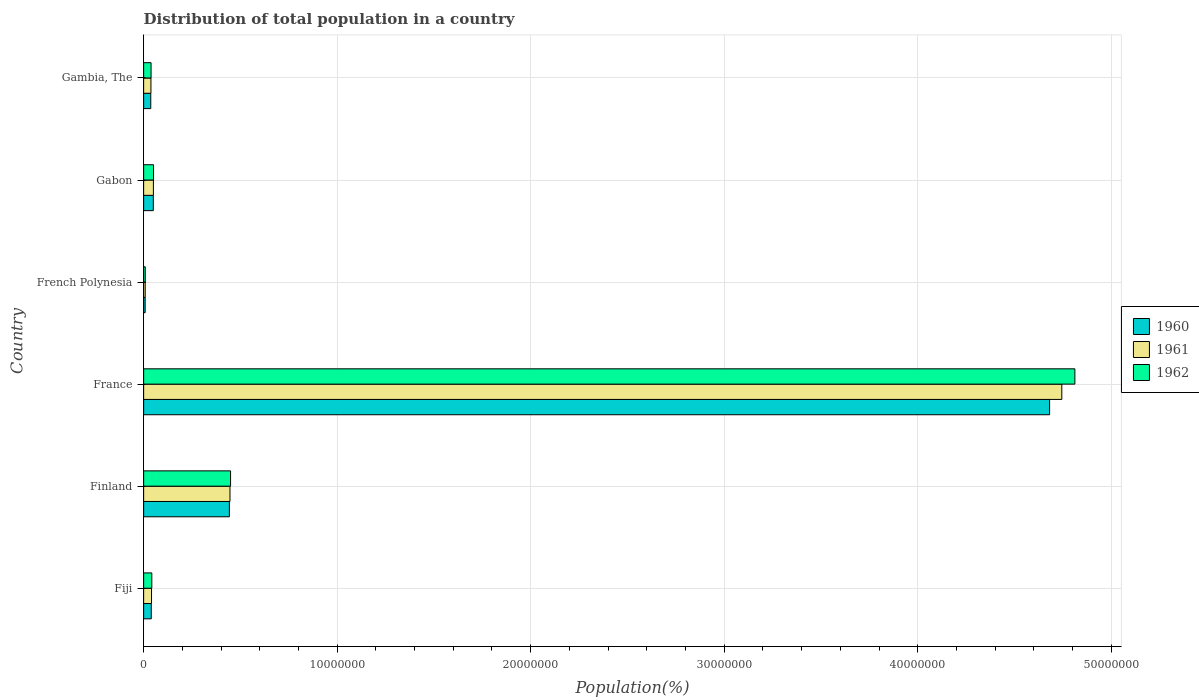What is the label of the 2nd group of bars from the top?
Keep it short and to the point. Gabon. In how many cases, is the number of bars for a given country not equal to the number of legend labels?
Give a very brief answer. 0. What is the population of in 1962 in Gabon?
Your answer should be compact. 5.10e+05. Across all countries, what is the maximum population of in 1960?
Provide a succinct answer. 4.68e+07. Across all countries, what is the minimum population of in 1961?
Provide a succinct answer. 8.07e+04. In which country was the population of in 1961 maximum?
Make the answer very short. France. In which country was the population of in 1960 minimum?
Ensure brevity in your answer.  French Polynesia. What is the total population of in 1962 in the graph?
Offer a very short reply. 5.40e+07. What is the difference between the population of in 1961 in Gabon and that in Gambia, The?
Your response must be concise. 1.27e+05. What is the difference between the population of in 1962 in Gambia, The and the population of in 1960 in Fiji?
Offer a very short reply. -9858. What is the average population of in 1961 per country?
Offer a terse response. 8.88e+06. What is the difference between the population of in 1962 and population of in 1961 in French Polynesia?
Ensure brevity in your answer.  2948. In how many countries, is the population of in 1962 greater than 46000000 %?
Your answer should be very brief. 1. What is the ratio of the population of in 1962 in Finland to that in Gambia, The?
Your response must be concise. 11.71. Is the difference between the population of in 1962 in Fiji and Gambia, The greater than the difference between the population of in 1961 in Fiji and Gambia, The?
Offer a terse response. Yes. What is the difference between the highest and the second highest population of in 1961?
Ensure brevity in your answer.  4.30e+07. What is the difference between the highest and the lowest population of in 1960?
Your answer should be very brief. 4.67e+07. What does the 2nd bar from the top in Gabon represents?
Your answer should be very brief. 1961. What does the 1st bar from the bottom in French Polynesia represents?
Make the answer very short. 1960. Is it the case that in every country, the sum of the population of in 1961 and population of in 1960 is greater than the population of in 1962?
Offer a very short reply. Yes. How many bars are there?
Your response must be concise. 18. How many countries are there in the graph?
Provide a succinct answer. 6. What is the difference between two consecutive major ticks on the X-axis?
Make the answer very short. 1.00e+07. Are the values on the major ticks of X-axis written in scientific E-notation?
Your response must be concise. No. How are the legend labels stacked?
Give a very brief answer. Vertical. What is the title of the graph?
Offer a very short reply. Distribution of total population in a country. Does "1968" appear as one of the legend labels in the graph?
Your response must be concise. No. What is the label or title of the X-axis?
Keep it short and to the point. Population(%). What is the Population(%) of 1960 in Fiji?
Offer a terse response. 3.93e+05. What is the Population(%) in 1961 in Fiji?
Keep it short and to the point. 4.07e+05. What is the Population(%) in 1962 in Fiji?
Provide a short and direct response. 4.22e+05. What is the Population(%) in 1960 in Finland?
Make the answer very short. 4.43e+06. What is the Population(%) in 1961 in Finland?
Your answer should be very brief. 4.46e+06. What is the Population(%) in 1962 in Finland?
Make the answer very short. 4.49e+06. What is the Population(%) in 1960 in France?
Your answer should be compact. 4.68e+07. What is the Population(%) in 1961 in France?
Ensure brevity in your answer.  4.74e+07. What is the Population(%) of 1962 in France?
Your response must be concise. 4.81e+07. What is the Population(%) in 1960 in French Polynesia?
Offer a very short reply. 7.81e+04. What is the Population(%) of 1961 in French Polynesia?
Your answer should be very brief. 8.07e+04. What is the Population(%) of 1962 in French Polynesia?
Make the answer very short. 8.37e+04. What is the Population(%) in 1960 in Gabon?
Make the answer very short. 4.99e+05. What is the Population(%) of 1961 in Gabon?
Keep it short and to the point. 5.04e+05. What is the Population(%) of 1962 in Gabon?
Ensure brevity in your answer.  5.10e+05. What is the Population(%) in 1960 in Gambia, The?
Your response must be concise. 3.68e+05. What is the Population(%) of 1961 in Gambia, The?
Ensure brevity in your answer.  3.77e+05. What is the Population(%) of 1962 in Gambia, The?
Offer a very short reply. 3.84e+05. Across all countries, what is the maximum Population(%) of 1960?
Give a very brief answer. 4.68e+07. Across all countries, what is the maximum Population(%) in 1961?
Ensure brevity in your answer.  4.74e+07. Across all countries, what is the maximum Population(%) of 1962?
Ensure brevity in your answer.  4.81e+07. Across all countries, what is the minimum Population(%) of 1960?
Provide a succinct answer. 7.81e+04. Across all countries, what is the minimum Population(%) in 1961?
Ensure brevity in your answer.  8.07e+04. Across all countries, what is the minimum Population(%) in 1962?
Make the answer very short. 8.37e+04. What is the total Population(%) in 1960 in the graph?
Give a very brief answer. 5.26e+07. What is the total Population(%) of 1961 in the graph?
Your answer should be compact. 5.33e+07. What is the total Population(%) of 1962 in the graph?
Your answer should be very brief. 5.40e+07. What is the difference between the Population(%) of 1960 in Fiji and that in Finland?
Your answer should be compact. -4.04e+06. What is the difference between the Population(%) of 1961 in Fiji and that in Finland?
Give a very brief answer. -4.05e+06. What is the difference between the Population(%) in 1962 in Fiji and that in Finland?
Keep it short and to the point. -4.07e+06. What is the difference between the Population(%) of 1960 in Fiji and that in France?
Your answer should be very brief. -4.64e+07. What is the difference between the Population(%) of 1961 in Fiji and that in France?
Give a very brief answer. -4.70e+07. What is the difference between the Population(%) of 1962 in Fiji and that in France?
Provide a short and direct response. -4.77e+07. What is the difference between the Population(%) in 1960 in Fiji and that in French Polynesia?
Ensure brevity in your answer.  3.15e+05. What is the difference between the Population(%) in 1961 in Fiji and that in French Polynesia?
Give a very brief answer. 3.26e+05. What is the difference between the Population(%) in 1962 in Fiji and that in French Polynesia?
Your response must be concise. 3.38e+05. What is the difference between the Population(%) of 1960 in Fiji and that in Gabon?
Make the answer very short. -1.06e+05. What is the difference between the Population(%) of 1961 in Fiji and that in Gabon?
Give a very brief answer. -9.70e+04. What is the difference between the Population(%) in 1962 in Fiji and that in Gabon?
Offer a very short reply. -8.82e+04. What is the difference between the Population(%) of 1960 in Fiji and that in Gambia, The?
Provide a short and direct response. 2.55e+04. What is the difference between the Population(%) of 1961 in Fiji and that in Gambia, The?
Keep it short and to the point. 3.04e+04. What is the difference between the Population(%) of 1962 in Fiji and that in Gambia, The?
Give a very brief answer. 3.81e+04. What is the difference between the Population(%) in 1960 in Finland and that in France?
Your answer should be very brief. -4.24e+07. What is the difference between the Population(%) in 1961 in Finland and that in France?
Give a very brief answer. -4.30e+07. What is the difference between the Population(%) in 1962 in Finland and that in France?
Make the answer very short. -4.36e+07. What is the difference between the Population(%) of 1960 in Finland and that in French Polynesia?
Your answer should be compact. 4.35e+06. What is the difference between the Population(%) in 1961 in Finland and that in French Polynesia?
Your answer should be very brief. 4.38e+06. What is the difference between the Population(%) in 1962 in Finland and that in French Polynesia?
Your answer should be very brief. 4.41e+06. What is the difference between the Population(%) of 1960 in Finland and that in Gabon?
Offer a terse response. 3.93e+06. What is the difference between the Population(%) in 1961 in Finland and that in Gabon?
Make the answer very short. 3.96e+06. What is the difference between the Population(%) in 1962 in Finland and that in Gabon?
Ensure brevity in your answer.  3.98e+06. What is the difference between the Population(%) of 1960 in Finland and that in Gambia, The?
Give a very brief answer. 4.06e+06. What is the difference between the Population(%) of 1961 in Finland and that in Gambia, The?
Provide a succinct answer. 4.08e+06. What is the difference between the Population(%) of 1962 in Finland and that in Gambia, The?
Ensure brevity in your answer.  4.11e+06. What is the difference between the Population(%) of 1960 in France and that in French Polynesia?
Your answer should be very brief. 4.67e+07. What is the difference between the Population(%) of 1961 in France and that in French Polynesia?
Give a very brief answer. 4.74e+07. What is the difference between the Population(%) of 1962 in France and that in French Polynesia?
Make the answer very short. 4.80e+07. What is the difference between the Population(%) in 1960 in France and that in Gabon?
Your response must be concise. 4.63e+07. What is the difference between the Population(%) in 1961 in France and that in Gabon?
Ensure brevity in your answer.  4.69e+07. What is the difference between the Population(%) of 1962 in France and that in Gabon?
Give a very brief answer. 4.76e+07. What is the difference between the Population(%) of 1960 in France and that in Gambia, The?
Your response must be concise. 4.64e+07. What is the difference between the Population(%) of 1961 in France and that in Gambia, The?
Your answer should be compact. 4.71e+07. What is the difference between the Population(%) in 1962 in France and that in Gambia, The?
Ensure brevity in your answer.  4.77e+07. What is the difference between the Population(%) in 1960 in French Polynesia and that in Gabon?
Provide a short and direct response. -4.21e+05. What is the difference between the Population(%) of 1961 in French Polynesia and that in Gabon?
Provide a succinct answer. -4.23e+05. What is the difference between the Population(%) of 1962 in French Polynesia and that in Gabon?
Your answer should be very brief. -4.26e+05. What is the difference between the Population(%) in 1960 in French Polynesia and that in Gambia, The?
Provide a short and direct response. -2.90e+05. What is the difference between the Population(%) in 1961 in French Polynesia and that in Gambia, The?
Offer a very short reply. -2.96e+05. What is the difference between the Population(%) in 1962 in French Polynesia and that in Gambia, The?
Make the answer very short. -3.00e+05. What is the difference between the Population(%) in 1960 in Gabon and that in Gambia, The?
Offer a terse response. 1.31e+05. What is the difference between the Population(%) in 1961 in Gabon and that in Gambia, The?
Ensure brevity in your answer.  1.27e+05. What is the difference between the Population(%) in 1962 in Gabon and that in Gambia, The?
Ensure brevity in your answer.  1.26e+05. What is the difference between the Population(%) in 1960 in Fiji and the Population(%) in 1961 in Finland?
Provide a succinct answer. -4.07e+06. What is the difference between the Population(%) in 1960 in Fiji and the Population(%) in 1962 in Finland?
Keep it short and to the point. -4.10e+06. What is the difference between the Population(%) of 1961 in Fiji and the Population(%) of 1962 in Finland?
Make the answer very short. -4.08e+06. What is the difference between the Population(%) in 1960 in Fiji and the Population(%) in 1961 in France?
Provide a succinct answer. -4.71e+07. What is the difference between the Population(%) in 1960 in Fiji and the Population(%) in 1962 in France?
Give a very brief answer. -4.77e+07. What is the difference between the Population(%) of 1961 in Fiji and the Population(%) of 1962 in France?
Your answer should be very brief. -4.77e+07. What is the difference between the Population(%) of 1960 in Fiji and the Population(%) of 1961 in French Polynesia?
Provide a short and direct response. 3.13e+05. What is the difference between the Population(%) of 1960 in Fiji and the Population(%) of 1962 in French Polynesia?
Keep it short and to the point. 3.10e+05. What is the difference between the Population(%) in 1961 in Fiji and the Population(%) in 1962 in French Polynesia?
Provide a short and direct response. 3.23e+05. What is the difference between the Population(%) in 1960 in Fiji and the Population(%) in 1961 in Gabon?
Provide a short and direct response. -1.11e+05. What is the difference between the Population(%) of 1960 in Fiji and the Population(%) of 1962 in Gabon?
Offer a terse response. -1.16e+05. What is the difference between the Population(%) in 1961 in Fiji and the Population(%) in 1962 in Gabon?
Your answer should be compact. -1.03e+05. What is the difference between the Population(%) of 1960 in Fiji and the Population(%) of 1961 in Gambia, The?
Keep it short and to the point. 1.66e+04. What is the difference between the Population(%) in 1960 in Fiji and the Population(%) in 1962 in Gambia, The?
Your response must be concise. 9858. What is the difference between the Population(%) in 1961 in Fiji and the Population(%) in 1962 in Gambia, The?
Give a very brief answer. 2.36e+04. What is the difference between the Population(%) in 1960 in Finland and the Population(%) in 1961 in France?
Keep it short and to the point. -4.30e+07. What is the difference between the Population(%) in 1960 in Finland and the Population(%) in 1962 in France?
Offer a terse response. -4.37e+07. What is the difference between the Population(%) of 1961 in Finland and the Population(%) of 1962 in France?
Make the answer very short. -4.37e+07. What is the difference between the Population(%) in 1960 in Finland and the Population(%) in 1961 in French Polynesia?
Ensure brevity in your answer.  4.35e+06. What is the difference between the Population(%) of 1960 in Finland and the Population(%) of 1962 in French Polynesia?
Provide a succinct answer. 4.35e+06. What is the difference between the Population(%) in 1961 in Finland and the Population(%) in 1962 in French Polynesia?
Your response must be concise. 4.38e+06. What is the difference between the Population(%) in 1960 in Finland and the Population(%) in 1961 in Gabon?
Provide a succinct answer. 3.93e+06. What is the difference between the Population(%) in 1960 in Finland and the Population(%) in 1962 in Gabon?
Ensure brevity in your answer.  3.92e+06. What is the difference between the Population(%) of 1961 in Finland and the Population(%) of 1962 in Gabon?
Your answer should be very brief. 3.95e+06. What is the difference between the Population(%) of 1960 in Finland and the Population(%) of 1961 in Gambia, The?
Make the answer very short. 4.05e+06. What is the difference between the Population(%) of 1960 in Finland and the Population(%) of 1962 in Gambia, The?
Offer a terse response. 4.05e+06. What is the difference between the Population(%) of 1961 in Finland and the Population(%) of 1962 in Gambia, The?
Make the answer very short. 4.08e+06. What is the difference between the Population(%) in 1960 in France and the Population(%) in 1961 in French Polynesia?
Your answer should be very brief. 4.67e+07. What is the difference between the Population(%) in 1960 in France and the Population(%) in 1962 in French Polynesia?
Give a very brief answer. 4.67e+07. What is the difference between the Population(%) of 1961 in France and the Population(%) of 1962 in French Polynesia?
Offer a terse response. 4.74e+07. What is the difference between the Population(%) in 1960 in France and the Population(%) in 1961 in Gabon?
Give a very brief answer. 4.63e+07. What is the difference between the Population(%) in 1960 in France and the Population(%) in 1962 in Gabon?
Ensure brevity in your answer.  4.63e+07. What is the difference between the Population(%) of 1961 in France and the Population(%) of 1962 in Gabon?
Offer a very short reply. 4.69e+07. What is the difference between the Population(%) of 1960 in France and the Population(%) of 1961 in Gambia, The?
Make the answer very short. 4.64e+07. What is the difference between the Population(%) of 1960 in France and the Population(%) of 1962 in Gambia, The?
Give a very brief answer. 4.64e+07. What is the difference between the Population(%) of 1961 in France and the Population(%) of 1962 in Gambia, The?
Make the answer very short. 4.71e+07. What is the difference between the Population(%) in 1960 in French Polynesia and the Population(%) in 1961 in Gabon?
Provide a succinct answer. -4.26e+05. What is the difference between the Population(%) in 1960 in French Polynesia and the Population(%) in 1962 in Gabon?
Your response must be concise. -4.32e+05. What is the difference between the Population(%) of 1961 in French Polynesia and the Population(%) of 1962 in Gabon?
Offer a terse response. -4.29e+05. What is the difference between the Population(%) in 1960 in French Polynesia and the Population(%) in 1961 in Gambia, The?
Ensure brevity in your answer.  -2.99e+05. What is the difference between the Population(%) in 1960 in French Polynesia and the Population(%) in 1962 in Gambia, The?
Your answer should be very brief. -3.05e+05. What is the difference between the Population(%) in 1961 in French Polynesia and the Population(%) in 1962 in Gambia, The?
Provide a short and direct response. -3.03e+05. What is the difference between the Population(%) in 1960 in Gabon and the Population(%) in 1961 in Gambia, The?
Offer a very short reply. 1.22e+05. What is the difference between the Population(%) in 1960 in Gabon and the Population(%) in 1962 in Gambia, The?
Your answer should be very brief. 1.16e+05. What is the difference between the Population(%) in 1961 in Gabon and the Population(%) in 1962 in Gambia, The?
Ensure brevity in your answer.  1.21e+05. What is the average Population(%) in 1960 per country?
Your response must be concise. 8.76e+06. What is the average Population(%) of 1961 per country?
Make the answer very short. 8.88e+06. What is the average Population(%) of 1962 per country?
Give a very brief answer. 9.00e+06. What is the difference between the Population(%) of 1960 and Population(%) of 1961 in Fiji?
Your answer should be compact. -1.38e+04. What is the difference between the Population(%) in 1960 and Population(%) in 1962 in Fiji?
Your answer should be compact. -2.82e+04. What is the difference between the Population(%) of 1961 and Population(%) of 1962 in Fiji?
Your answer should be very brief. -1.44e+04. What is the difference between the Population(%) of 1960 and Population(%) of 1961 in Finland?
Offer a terse response. -3.14e+04. What is the difference between the Population(%) of 1960 and Population(%) of 1962 in Finland?
Your response must be concise. -6.18e+04. What is the difference between the Population(%) in 1961 and Population(%) in 1962 in Finland?
Keep it short and to the point. -3.04e+04. What is the difference between the Population(%) in 1960 and Population(%) in 1961 in France?
Keep it short and to the point. -6.31e+05. What is the difference between the Population(%) of 1960 and Population(%) of 1962 in France?
Your answer should be very brief. -1.31e+06. What is the difference between the Population(%) in 1961 and Population(%) in 1962 in France?
Give a very brief answer. -6.75e+05. What is the difference between the Population(%) in 1960 and Population(%) in 1961 in French Polynesia?
Keep it short and to the point. -2623. What is the difference between the Population(%) in 1960 and Population(%) in 1962 in French Polynesia?
Offer a terse response. -5571. What is the difference between the Population(%) in 1961 and Population(%) in 1962 in French Polynesia?
Provide a succinct answer. -2948. What is the difference between the Population(%) in 1960 and Population(%) in 1961 in Gabon?
Make the answer very short. -4985. What is the difference between the Population(%) of 1960 and Population(%) of 1962 in Gabon?
Provide a short and direct response. -1.06e+04. What is the difference between the Population(%) of 1961 and Population(%) of 1962 in Gabon?
Make the answer very short. -5632. What is the difference between the Population(%) in 1960 and Population(%) in 1961 in Gambia, The?
Your response must be concise. -8807. What is the difference between the Population(%) in 1960 and Population(%) in 1962 in Gambia, The?
Your response must be concise. -1.56e+04. What is the difference between the Population(%) in 1961 and Population(%) in 1962 in Gambia, The?
Offer a terse response. -6789. What is the ratio of the Population(%) in 1960 in Fiji to that in Finland?
Your answer should be compact. 0.09. What is the ratio of the Population(%) in 1961 in Fiji to that in Finland?
Make the answer very short. 0.09. What is the ratio of the Population(%) of 1962 in Fiji to that in Finland?
Your answer should be very brief. 0.09. What is the ratio of the Population(%) of 1960 in Fiji to that in France?
Offer a very short reply. 0.01. What is the ratio of the Population(%) of 1961 in Fiji to that in France?
Give a very brief answer. 0.01. What is the ratio of the Population(%) in 1962 in Fiji to that in France?
Ensure brevity in your answer.  0.01. What is the ratio of the Population(%) of 1960 in Fiji to that in French Polynesia?
Ensure brevity in your answer.  5.04. What is the ratio of the Population(%) in 1961 in Fiji to that in French Polynesia?
Ensure brevity in your answer.  5.04. What is the ratio of the Population(%) of 1962 in Fiji to that in French Polynesia?
Give a very brief answer. 5.04. What is the ratio of the Population(%) in 1960 in Fiji to that in Gabon?
Give a very brief answer. 0.79. What is the ratio of the Population(%) of 1961 in Fiji to that in Gabon?
Provide a short and direct response. 0.81. What is the ratio of the Population(%) in 1962 in Fiji to that in Gabon?
Your response must be concise. 0.83. What is the ratio of the Population(%) in 1960 in Fiji to that in Gambia, The?
Offer a terse response. 1.07. What is the ratio of the Population(%) of 1961 in Fiji to that in Gambia, The?
Give a very brief answer. 1.08. What is the ratio of the Population(%) of 1962 in Fiji to that in Gambia, The?
Your answer should be very brief. 1.1. What is the ratio of the Population(%) in 1960 in Finland to that in France?
Give a very brief answer. 0.09. What is the ratio of the Population(%) of 1961 in Finland to that in France?
Offer a very short reply. 0.09. What is the ratio of the Population(%) in 1962 in Finland to that in France?
Keep it short and to the point. 0.09. What is the ratio of the Population(%) in 1960 in Finland to that in French Polynesia?
Your response must be concise. 56.73. What is the ratio of the Population(%) of 1961 in Finland to that in French Polynesia?
Offer a very short reply. 55.27. What is the ratio of the Population(%) of 1962 in Finland to that in French Polynesia?
Give a very brief answer. 53.69. What is the ratio of the Population(%) in 1960 in Finland to that in Gabon?
Your response must be concise. 8.87. What is the ratio of the Population(%) in 1961 in Finland to that in Gabon?
Give a very brief answer. 8.85. What is the ratio of the Population(%) in 1962 in Finland to that in Gabon?
Give a very brief answer. 8.81. What is the ratio of the Population(%) in 1960 in Finland to that in Gambia, The?
Make the answer very short. 12.04. What is the ratio of the Population(%) of 1961 in Finland to that in Gambia, The?
Keep it short and to the point. 11.84. What is the ratio of the Population(%) of 1962 in Finland to that in Gambia, The?
Offer a terse response. 11.71. What is the ratio of the Population(%) of 1960 in France to that in French Polynesia?
Keep it short and to the point. 599.54. What is the ratio of the Population(%) in 1961 in France to that in French Polynesia?
Make the answer very short. 587.87. What is the ratio of the Population(%) in 1962 in France to that in French Polynesia?
Keep it short and to the point. 575.22. What is the ratio of the Population(%) in 1960 in France to that in Gabon?
Provide a succinct answer. 93.78. What is the ratio of the Population(%) of 1961 in France to that in Gabon?
Make the answer very short. 94.1. What is the ratio of the Population(%) in 1962 in France to that in Gabon?
Make the answer very short. 94.39. What is the ratio of the Population(%) of 1960 in France to that in Gambia, The?
Offer a very short reply. 127.24. What is the ratio of the Population(%) in 1961 in France to that in Gambia, The?
Keep it short and to the point. 125.94. What is the ratio of the Population(%) in 1962 in France to that in Gambia, The?
Provide a short and direct response. 125.47. What is the ratio of the Population(%) in 1960 in French Polynesia to that in Gabon?
Your response must be concise. 0.16. What is the ratio of the Population(%) of 1961 in French Polynesia to that in Gabon?
Your answer should be compact. 0.16. What is the ratio of the Population(%) in 1962 in French Polynesia to that in Gabon?
Give a very brief answer. 0.16. What is the ratio of the Population(%) in 1960 in French Polynesia to that in Gambia, The?
Make the answer very short. 0.21. What is the ratio of the Population(%) of 1961 in French Polynesia to that in Gambia, The?
Make the answer very short. 0.21. What is the ratio of the Population(%) in 1962 in French Polynesia to that in Gambia, The?
Your response must be concise. 0.22. What is the ratio of the Population(%) of 1960 in Gabon to that in Gambia, The?
Offer a very short reply. 1.36. What is the ratio of the Population(%) in 1961 in Gabon to that in Gambia, The?
Your response must be concise. 1.34. What is the ratio of the Population(%) in 1962 in Gabon to that in Gambia, The?
Provide a short and direct response. 1.33. What is the difference between the highest and the second highest Population(%) of 1960?
Provide a succinct answer. 4.24e+07. What is the difference between the highest and the second highest Population(%) of 1961?
Your answer should be compact. 4.30e+07. What is the difference between the highest and the second highest Population(%) in 1962?
Offer a very short reply. 4.36e+07. What is the difference between the highest and the lowest Population(%) of 1960?
Make the answer very short. 4.67e+07. What is the difference between the highest and the lowest Population(%) in 1961?
Offer a very short reply. 4.74e+07. What is the difference between the highest and the lowest Population(%) of 1962?
Your answer should be very brief. 4.80e+07. 